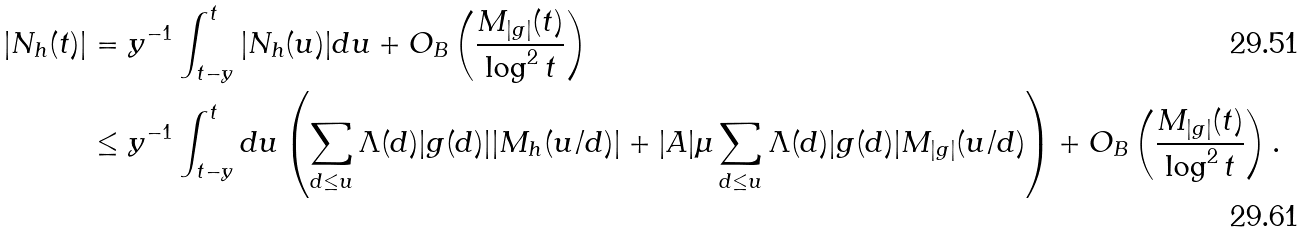Convert formula to latex. <formula><loc_0><loc_0><loc_500><loc_500>| N _ { h } ( t ) | & = y ^ { - 1 } \int _ { t - y } ^ { t } | N _ { h } ( u ) | d u + O _ { B } \left ( \frac { M _ { | g | } ( t ) } { \log ^ { 2 } t } \right ) \\ & \leq y ^ { - 1 } \int _ { t - y } ^ { t } d u \left ( \sum _ { d \leq u } \Lambda ( d ) | g ( d ) | | M _ { h } ( u / d ) | + | A | \mu \sum _ { d \leq u } \Lambda ( d ) | g ( d ) | M _ { | g | } ( u / d ) \right ) + O _ { B } \left ( \frac { M _ { | g | } ( t ) } { \log ^ { 2 } t } \right ) .</formula> 